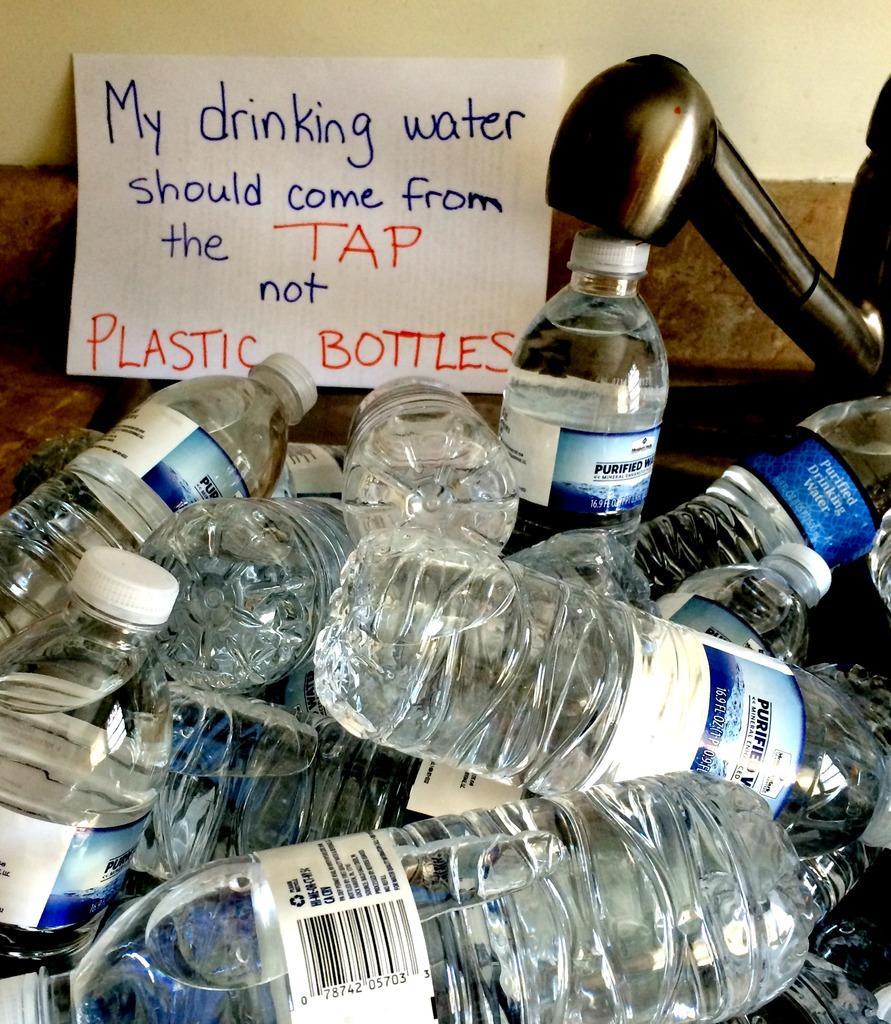In one or two sentences, can you explain what this image depicts? In this image we can see few water bottles with labels. This is the card written a note on it. 